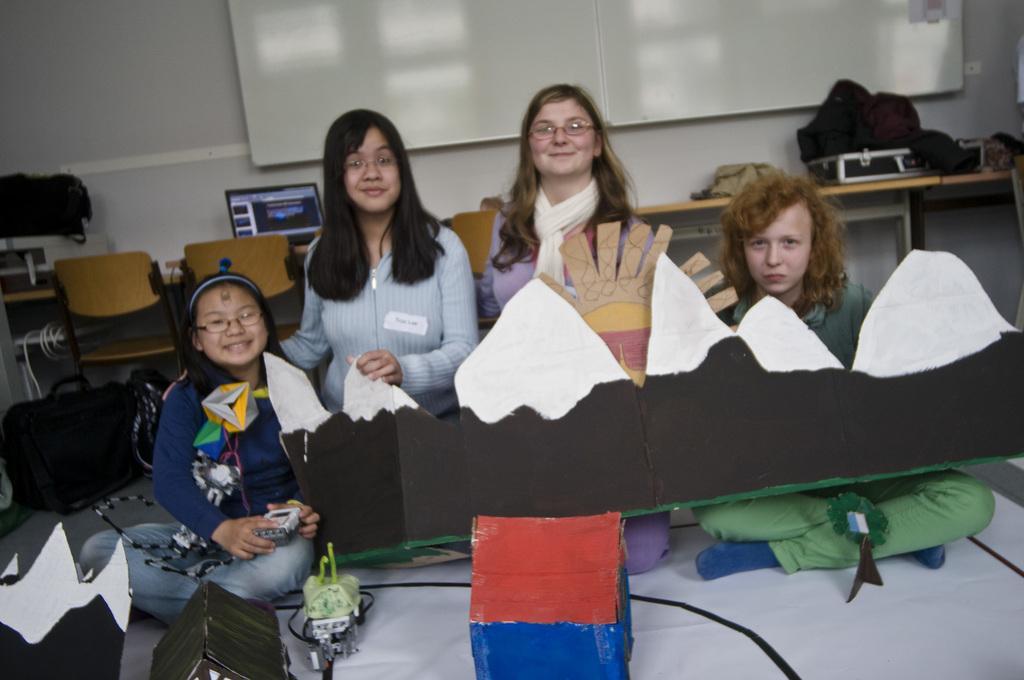How would you summarize this image in a sentence or two? In this image there are few people in the room, there are a few chairs, a laptop and some objects on the table, a board attached to the wall and some cardboard boxes. 